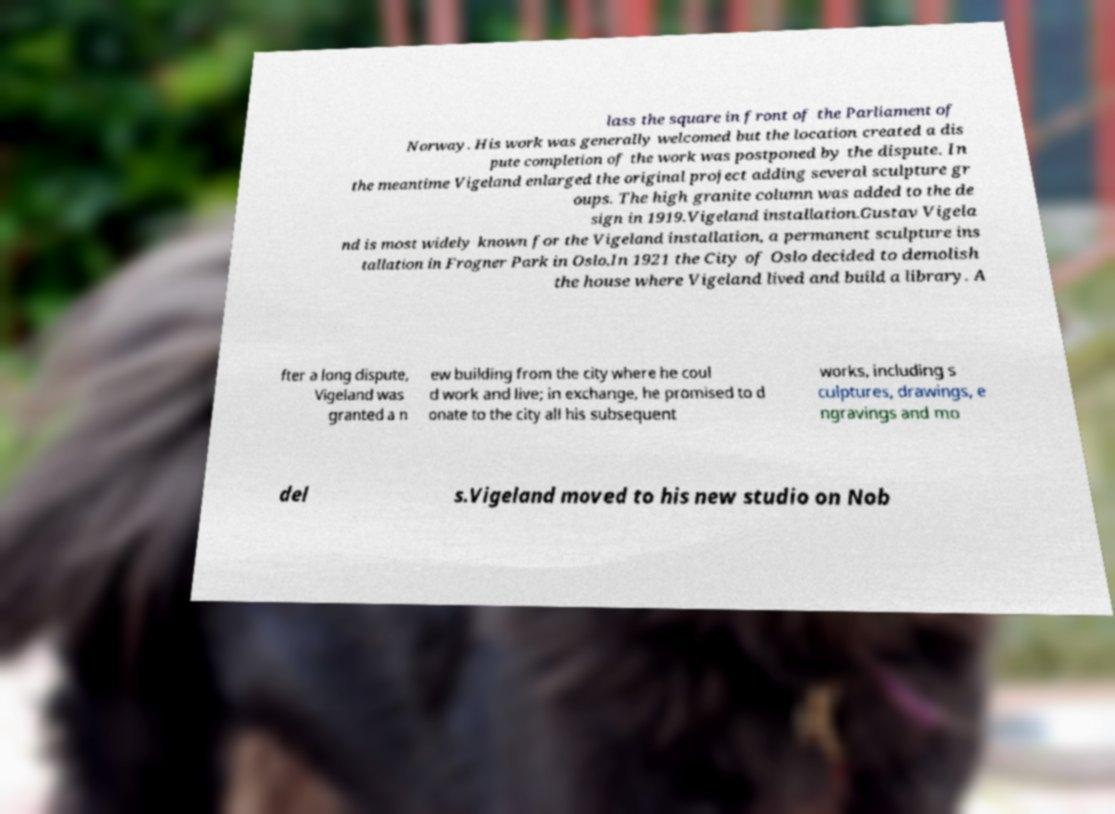Can you accurately transcribe the text from the provided image for me? lass the square in front of the Parliament of Norway. His work was generally welcomed but the location created a dis pute completion of the work was postponed by the dispute. In the meantime Vigeland enlarged the original project adding several sculpture gr oups. The high granite column was added to the de sign in 1919.Vigeland installation.Gustav Vigela nd is most widely known for the Vigeland installation, a permanent sculpture ins tallation in Frogner Park in Oslo.In 1921 the City of Oslo decided to demolish the house where Vigeland lived and build a library. A fter a long dispute, Vigeland was granted a n ew building from the city where he coul d work and live; in exchange, he promised to d onate to the city all his subsequent works, including s culptures, drawings, e ngravings and mo del s.Vigeland moved to his new studio on Nob 